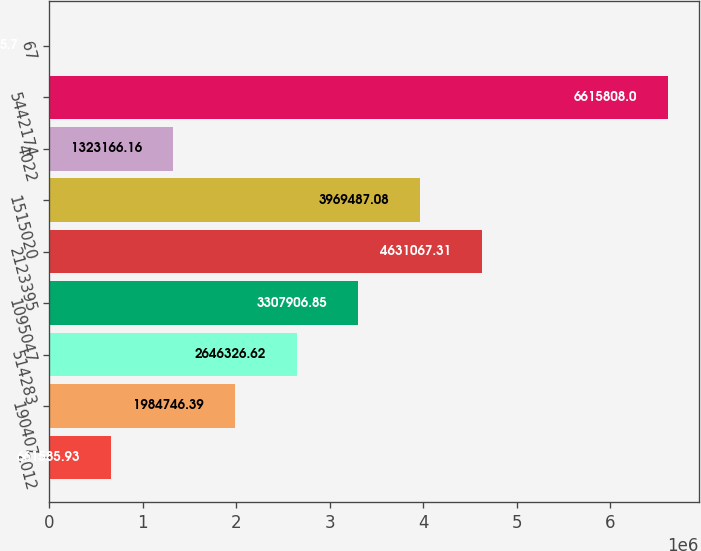Convert chart to OTSL. <chart><loc_0><loc_0><loc_500><loc_500><bar_chart><fcel>2012<fcel>190407<fcel>514283<fcel>1095047<fcel>2123395<fcel>1515020<fcel>4022<fcel>5442174<fcel>67<nl><fcel>661586<fcel>1.98475e+06<fcel>2.64633e+06<fcel>3.30791e+06<fcel>4.63107e+06<fcel>3.96949e+06<fcel>1.32317e+06<fcel>6.61581e+06<fcel>5.7<nl></chart> 